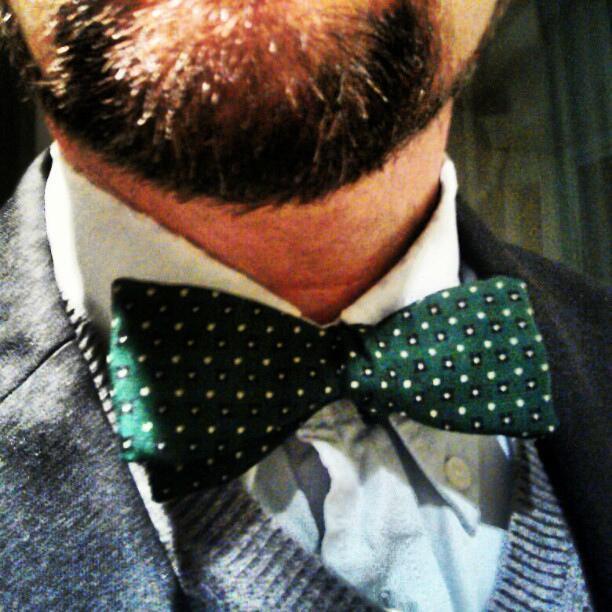How many clocks in the tower?
Give a very brief answer. 0. 